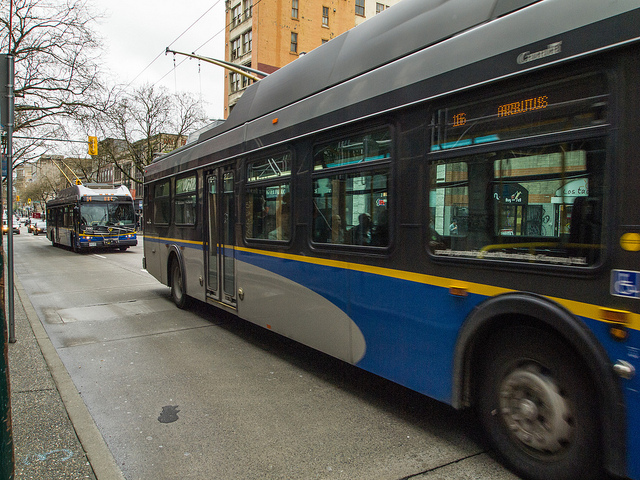Please transcribe the text in this image. 166 LOS 